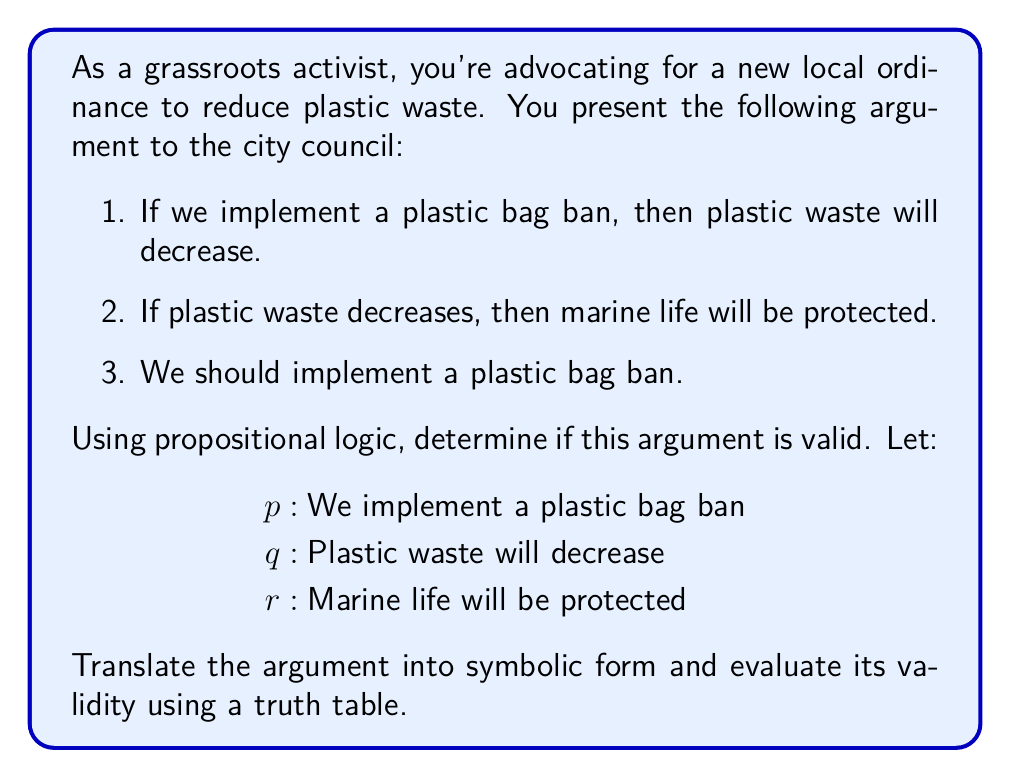Show me your answer to this math problem. Let's approach this step-by-step:

1) First, we translate the argument into symbolic form:
   Premise 1: $p \rightarrow q$
   Premise 2: $q \rightarrow r$
   Conclusion: $p$

2) The argument form is:
   $$(p \rightarrow q) \land (q \rightarrow r) \therefore p$$

3) This argument form is not valid because the conclusion doesn't follow logically from the premises. To prove this, we need to show that there's a case where the premises are true but the conclusion is false.

4) Let's construct a truth table:

   $$\begin{array}{|c|c|c|c|c|c|}
   \hline
   p & q & r & p \rightarrow q & q \rightarrow r & (p \rightarrow q) \land (q \rightarrow r) \\
   \hline
   T & T & T & T & T & T \\
   T & T & F & T & F & F \\
   T & F & T & F & T & F \\
   T & F & F & F & T & F \\
   F & T & T & T & T & T \\
   F & T & F & T & F & F \\
   F & F & T & T & T & T \\
   F & F & F & T & T & T \\
   \hline
   \end{array}$$

5) We can see that in the last row, both premises $(p \rightarrow q)$ and $(q \rightarrow r)$ are true, but the conclusion $p$ is false. This demonstrates that the argument is not valid.

6) In the context of advocacy, this means that while the logical connections between implementing a ban, reducing waste, and protecting marine life may be sound, the argument doesn't necessarily lead to the conclusion that we should implement the ban. Additional premises or a different logical structure would be needed to make this a valid argument.
Answer: Invalid argument 